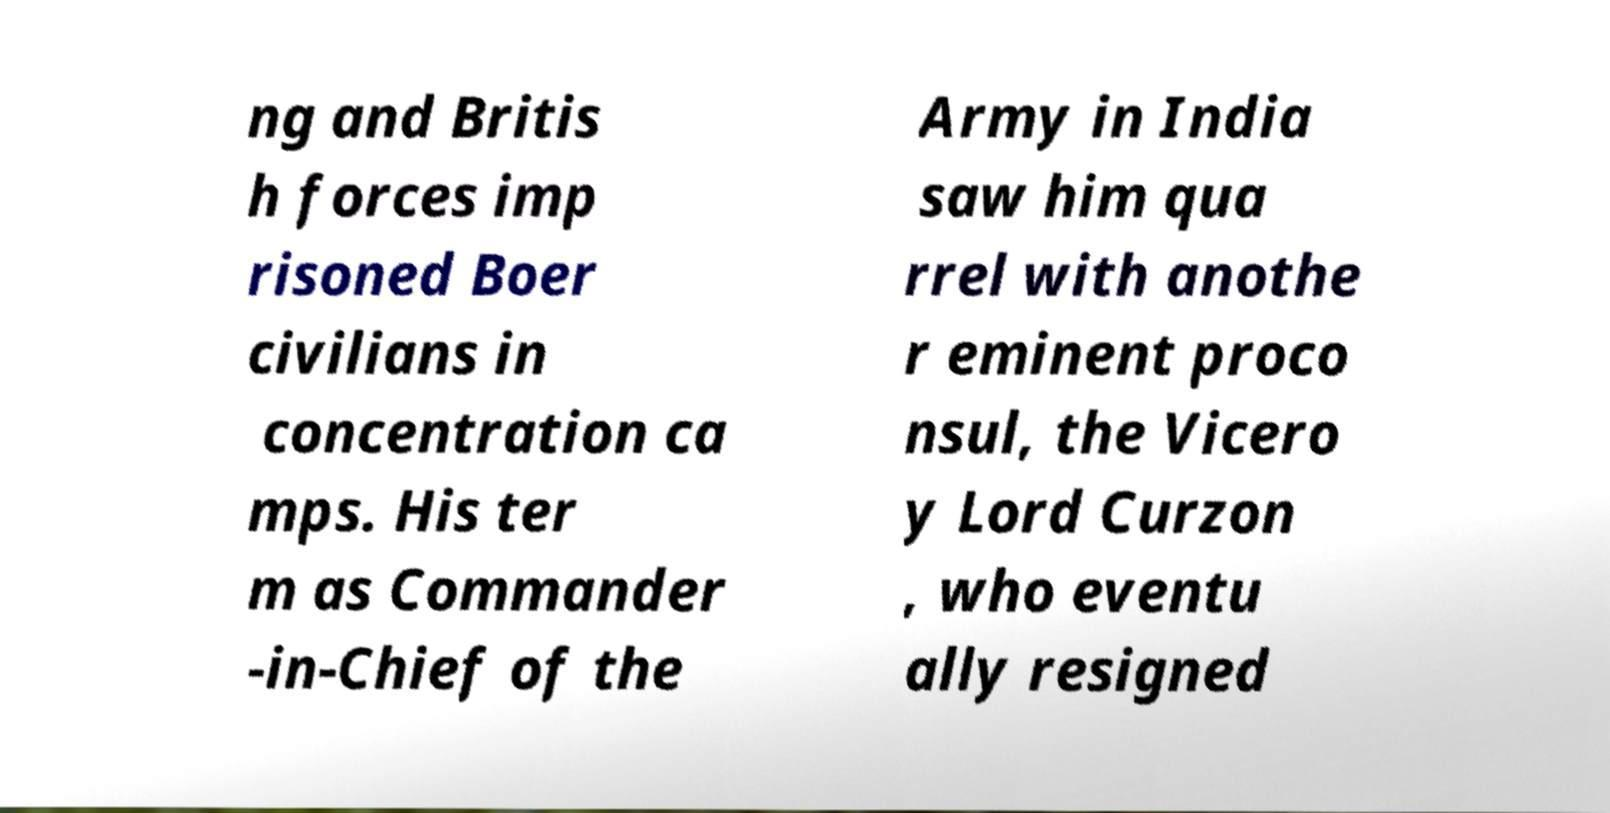Could you extract and type out the text from this image? ng and Britis h forces imp risoned Boer civilians in concentration ca mps. His ter m as Commander -in-Chief of the Army in India saw him qua rrel with anothe r eminent proco nsul, the Vicero y Lord Curzon , who eventu ally resigned 